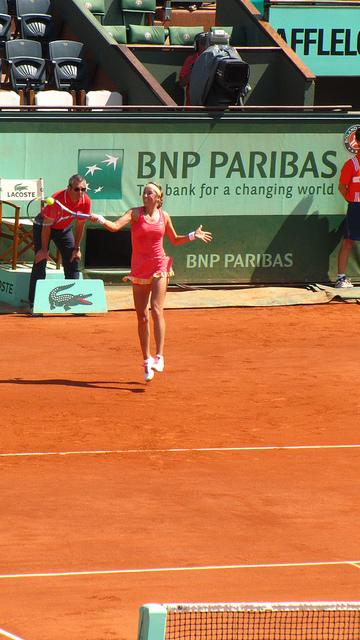What is the girl doing?
Answer briefly. Playing tennis. Which sport is this?
Be succinct. Tennis. What type of turf is being played on?
Be succinct. Clay. What color is the field?
Short answer required. Orange. 